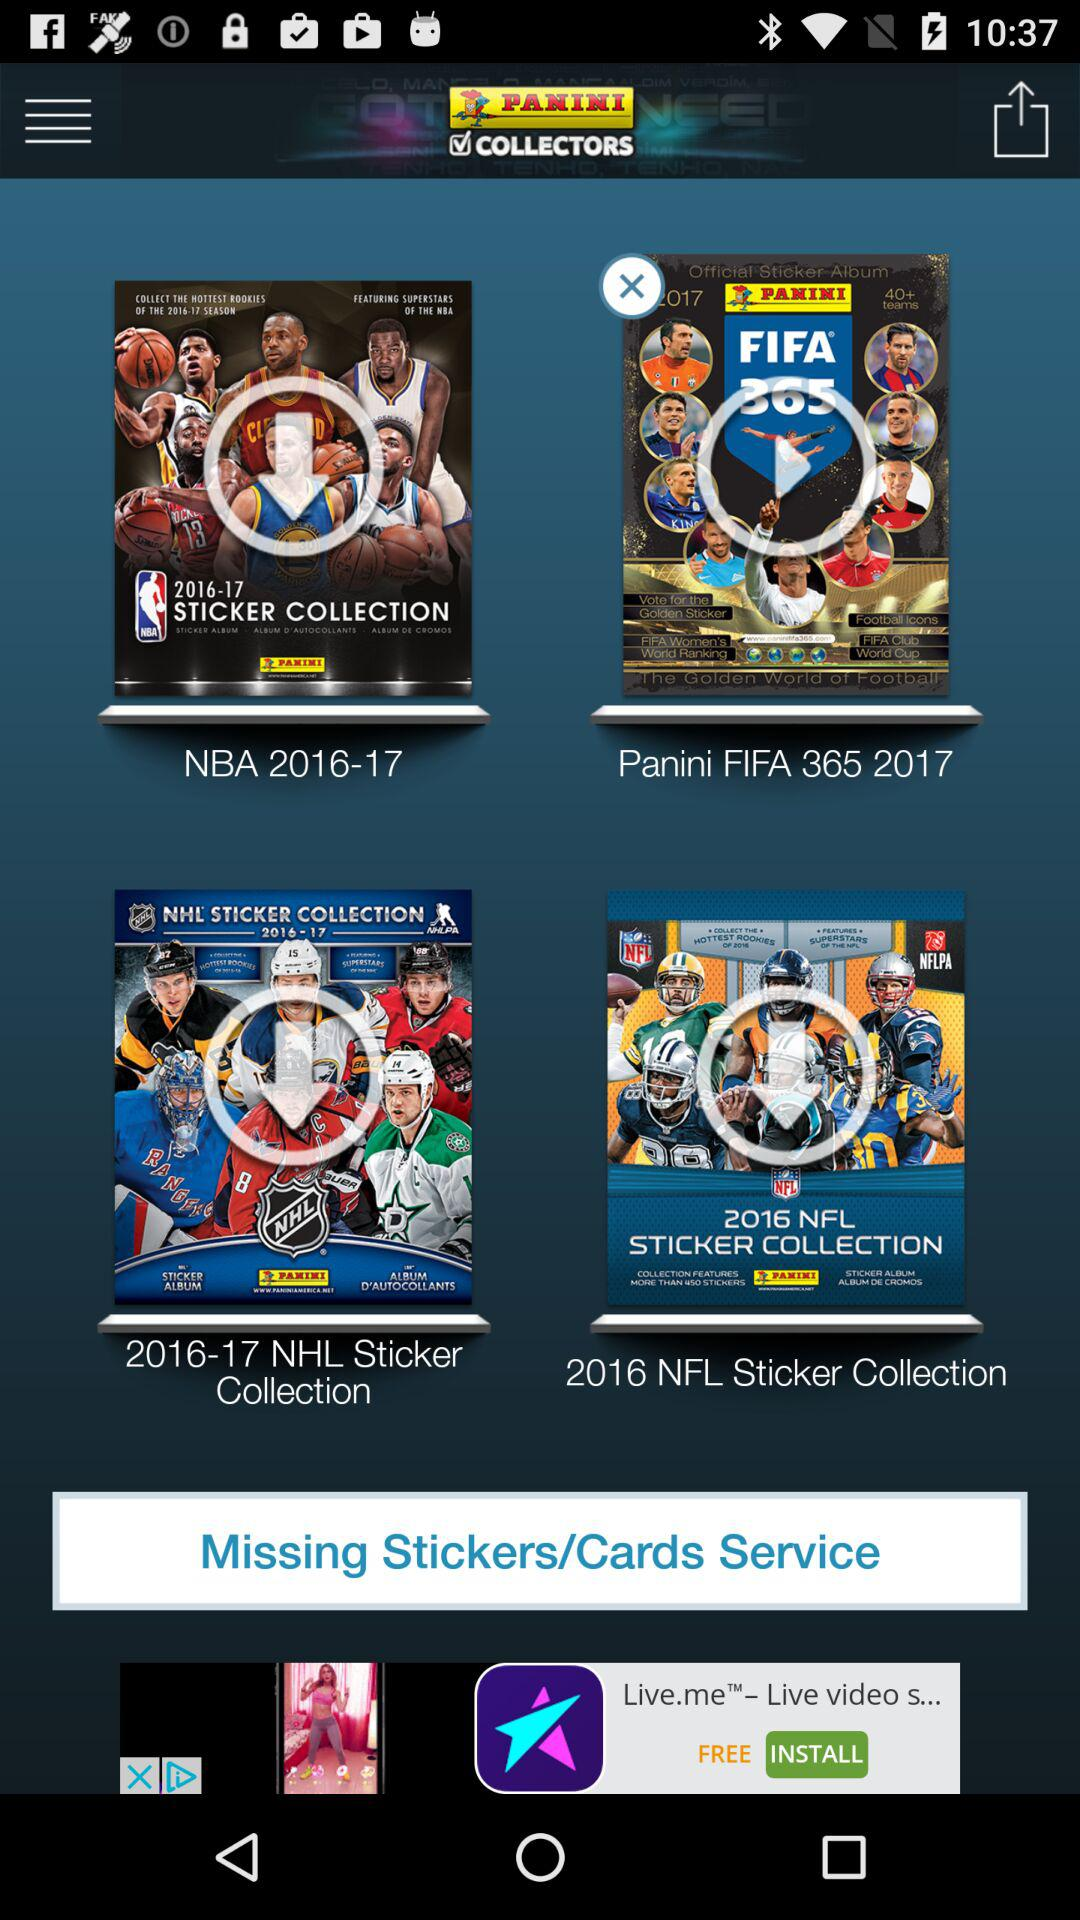What is the year "Panini FIFA 365"? The year is 2017. 